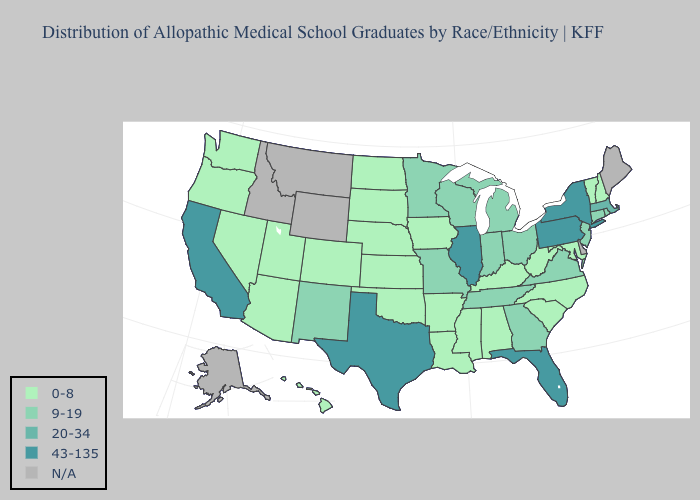How many symbols are there in the legend?
Quick response, please. 5. Name the states that have a value in the range 43-135?
Be succinct. California, Florida, Illinois, New York, Pennsylvania, Texas. Name the states that have a value in the range 43-135?
Concise answer only. California, Florida, Illinois, New York, Pennsylvania, Texas. What is the value of Wisconsin?
Write a very short answer. 9-19. Does South Dakota have the lowest value in the USA?
Concise answer only. Yes. How many symbols are there in the legend?
Answer briefly. 5. Name the states that have a value in the range 9-19?
Answer briefly. Connecticut, Georgia, Indiana, Michigan, Minnesota, Missouri, New Jersey, New Mexico, Ohio, Rhode Island, Tennessee, Virginia, Wisconsin. What is the highest value in the MidWest ?
Concise answer only. 43-135. What is the highest value in states that border Utah?
Short answer required. 9-19. Does Alabama have the highest value in the South?
Quick response, please. No. What is the value of Texas?
Be succinct. 43-135. Does the map have missing data?
Give a very brief answer. Yes. Name the states that have a value in the range 20-34?
Short answer required. Massachusetts. 